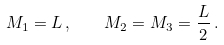Convert formula to latex. <formula><loc_0><loc_0><loc_500><loc_500>M _ { 1 } = L \, , \quad M _ { 2 } = M _ { 3 } = \frac { L } { 2 } \, .</formula> 